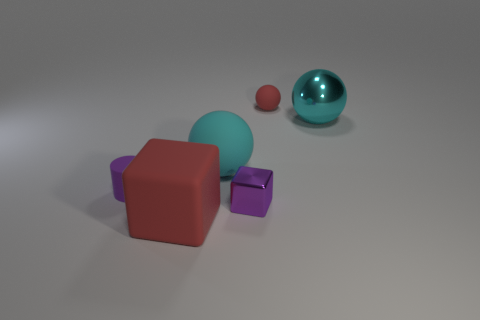Are there any cyan things? Yes, there is a cyan sphere located towards the right side of the image, appearing to have a reflective surface. 